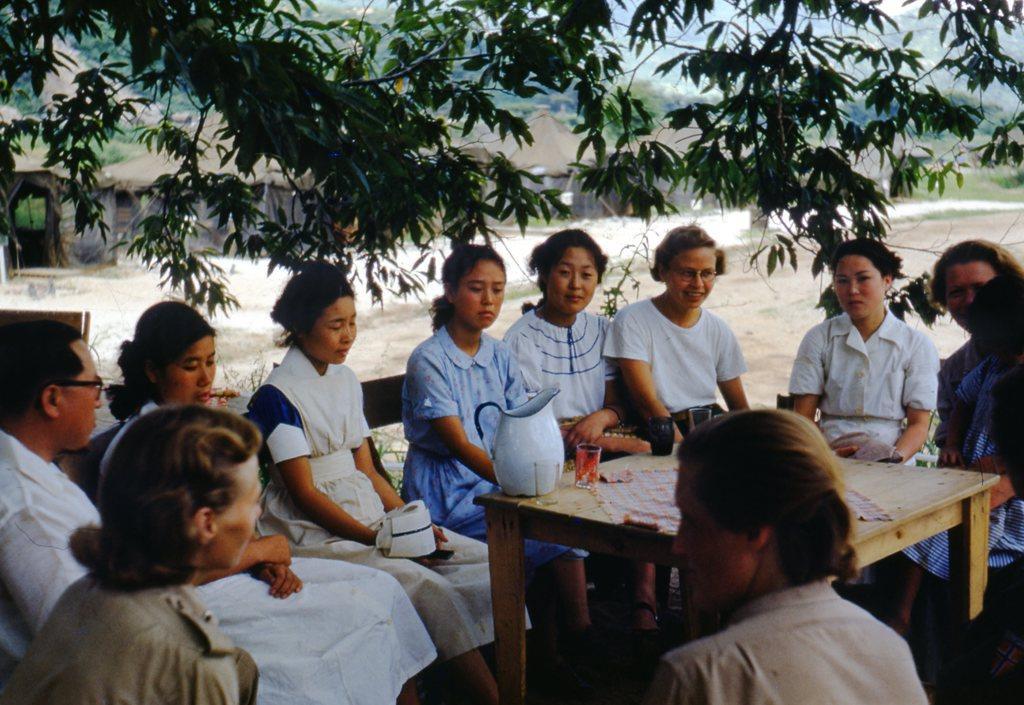Could you give a brief overview of what you see in this image? In this picture we can see some persons sitting on the chairs. This is table. On the table there is a jar and a glass. On the background there are some huts. And these are the trees. 